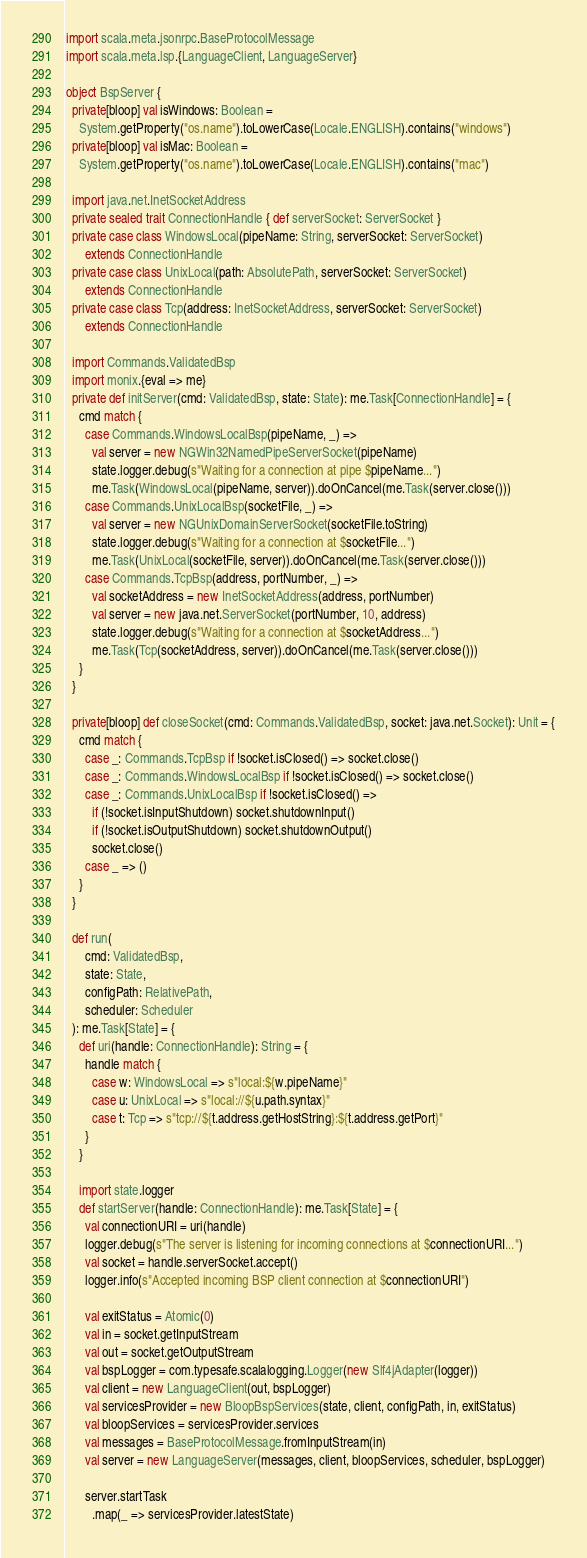Convert code to text. <code><loc_0><loc_0><loc_500><loc_500><_Scala_>
import scala.meta.jsonrpc.BaseProtocolMessage
import scala.meta.lsp.{LanguageClient, LanguageServer}

object BspServer {
  private[bloop] val isWindows: Boolean =
    System.getProperty("os.name").toLowerCase(Locale.ENGLISH).contains("windows")
  private[bloop] val isMac: Boolean =
    System.getProperty("os.name").toLowerCase(Locale.ENGLISH).contains("mac")

  import java.net.InetSocketAddress
  private sealed trait ConnectionHandle { def serverSocket: ServerSocket }
  private case class WindowsLocal(pipeName: String, serverSocket: ServerSocket)
      extends ConnectionHandle
  private case class UnixLocal(path: AbsolutePath, serverSocket: ServerSocket)
      extends ConnectionHandle
  private case class Tcp(address: InetSocketAddress, serverSocket: ServerSocket)
      extends ConnectionHandle

  import Commands.ValidatedBsp
  import monix.{eval => me}
  private def initServer(cmd: ValidatedBsp, state: State): me.Task[ConnectionHandle] = {
    cmd match {
      case Commands.WindowsLocalBsp(pipeName, _) =>
        val server = new NGWin32NamedPipeServerSocket(pipeName)
        state.logger.debug(s"Waiting for a connection at pipe $pipeName...")
        me.Task(WindowsLocal(pipeName, server)).doOnCancel(me.Task(server.close()))
      case Commands.UnixLocalBsp(socketFile, _) =>
        val server = new NGUnixDomainServerSocket(socketFile.toString)
        state.logger.debug(s"Waiting for a connection at $socketFile...")
        me.Task(UnixLocal(socketFile, server)).doOnCancel(me.Task(server.close()))
      case Commands.TcpBsp(address, portNumber, _) =>
        val socketAddress = new InetSocketAddress(address, portNumber)
        val server = new java.net.ServerSocket(portNumber, 10, address)
        state.logger.debug(s"Waiting for a connection at $socketAddress...")
        me.Task(Tcp(socketAddress, server)).doOnCancel(me.Task(server.close()))
    }
  }

  private[bloop] def closeSocket(cmd: Commands.ValidatedBsp, socket: java.net.Socket): Unit = {
    cmd match {
      case _: Commands.TcpBsp if !socket.isClosed() => socket.close()
      case _: Commands.WindowsLocalBsp if !socket.isClosed() => socket.close()
      case _: Commands.UnixLocalBsp if !socket.isClosed() =>
        if (!socket.isInputShutdown) socket.shutdownInput()
        if (!socket.isOutputShutdown) socket.shutdownOutput()
        socket.close()
      case _ => ()
    }
  }

  def run(
      cmd: ValidatedBsp,
      state: State,
      configPath: RelativePath,
      scheduler: Scheduler
  ): me.Task[State] = {
    def uri(handle: ConnectionHandle): String = {
      handle match {
        case w: WindowsLocal => s"local:${w.pipeName}"
        case u: UnixLocal => s"local://${u.path.syntax}"
        case t: Tcp => s"tcp://${t.address.getHostString}:${t.address.getPort}"
      }
    }

    import state.logger
    def startServer(handle: ConnectionHandle): me.Task[State] = {
      val connectionURI = uri(handle)
      logger.debug(s"The server is listening for incoming connections at $connectionURI...")
      val socket = handle.serverSocket.accept()
      logger.info(s"Accepted incoming BSP client connection at $connectionURI")

      val exitStatus = Atomic(0)
      val in = socket.getInputStream
      val out = socket.getOutputStream
      val bspLogger = com.typesafe.scalalogging.Logger(new Slf4jAdapter(logger))
      val client = new LanguageClient(out, bspLogger)
      val servicesProvider = new BloopBspServices(state, client, configPath, in, exitStatus)
      val bloopServices = servicesProvider.services
      val messages = BaseProtocolMessage.fromInputStream(in)
      val server = new LanguageServer(messages, client, bloopServices, scheduler, bspLogger)

      server.startTask
        .map(_ => servicesProvider.latestState)</code> 